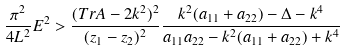<formula> <loc_0><loc_0><loc_500><loc_500>\frac { \pi ^ { 2 } } { 4 L ^ { 2 } } E ^ { 2 } > \frac { ( T r A - 2 k ^ { 2 } ) ^ { 2 } } { ( z _ { 1 } - z _ { 2 } ) ^ { 2 } } \frac { k ^ { 2 } ( a _ { 1 1 } + a _ { 2 2 } ) - \Delta - k ^ { 4 } } { a _ { 1 1 } a _ { 2 2 } - k ^ { 2 } ( a _ { 1 1 } + a _ { 2 2 } ) + k ^ { 4 } }</formula> 